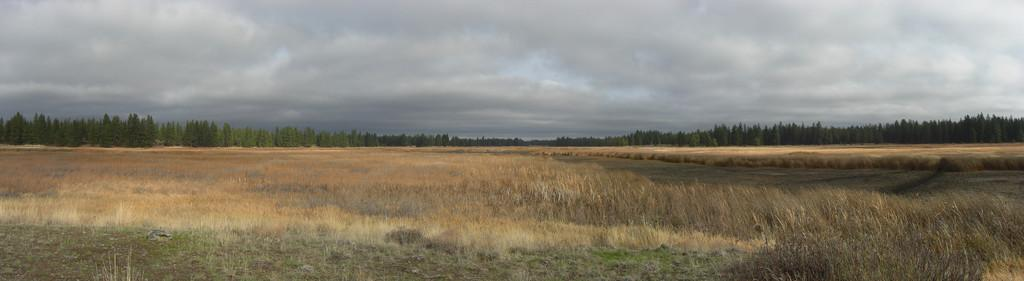What type of vegetation can be seen in the image? There is grass in the image. What other natural elements are present in the image? There are trees in the image. What can be seen in the background of the image? The sky is visible in the background of the image. What is the condition of the sky in the image? Clouds are present in the sky. What type of account does the uncle have in the image? There is no uncle or account present in the image. What is the crush doing in the image? There is no crush present in the image. 